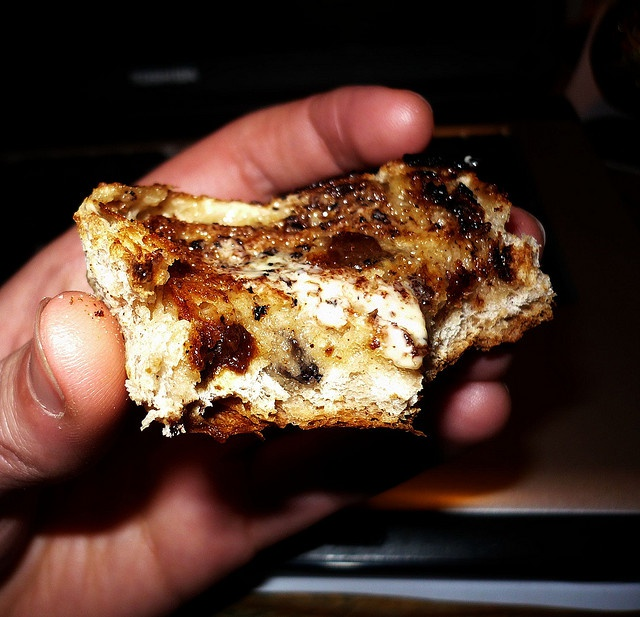Describe the objects in this image and their specific colors. I can see people in black, brown, maroon, and salmon tones and pizza in black, maroon, beige, and brown tones in this image. 